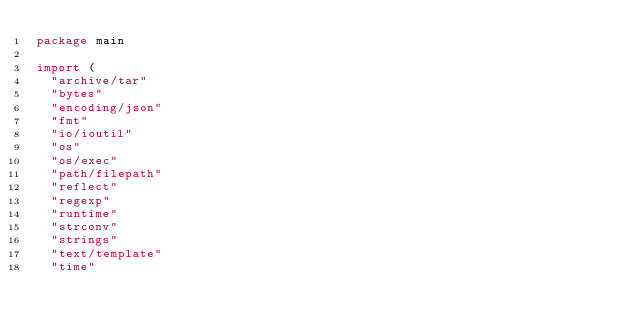Convert code to text. <code><loc_0><loc_0><loc_500><loc_500><_Go_>package main

import (
	"archive/tar"
	"bytes"
	"encoding/json"
	"fmt"
	"io/ioutil"
	"os"
	"os/exec"
	"path/filepath"
	"reflect"
	"regexp"
	"runtime"
	"strconv"
	"strings"
	"text/template"
	"time"
</code> 